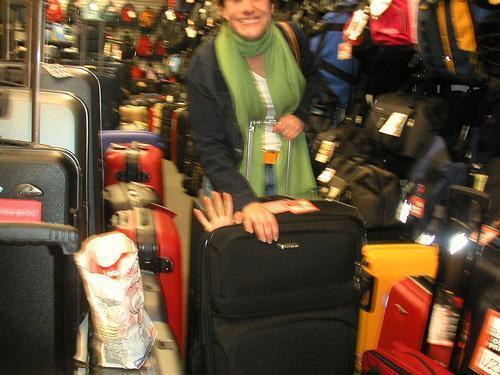How many backpacks are in the picture?
Give a very brief answer. 2. How many suitcases are in the picture?
Give a very brief answer. 10. How many skis are level against the snow?
Give a very brief answer. 0. 